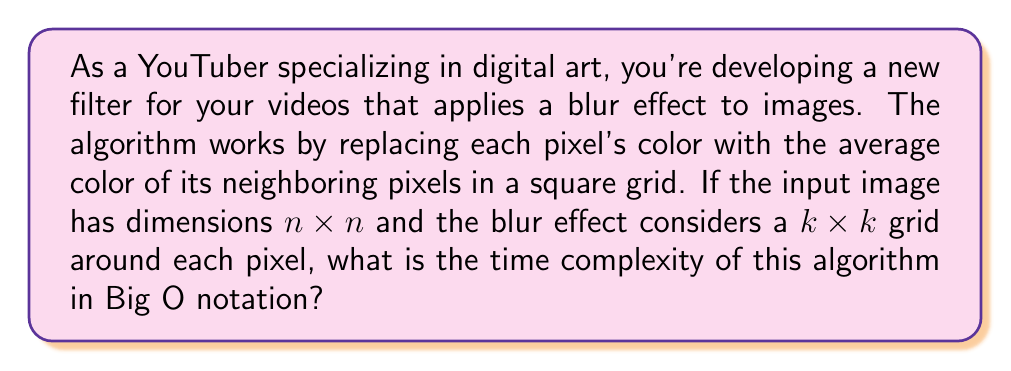Can you solve this math problem? Let's break down the problem and analyze the algorithm step by step:

1. The input image has dimensions $n \times n$, meaning there are $n^2$ total pixels to process.

2. For each pixel, we need to consider a $k \times k$ grid of neighboring pixels.

3. To calculate the average color for each pixel:
   a. We sum the color values of all pixels in the $k \times k$ grid.
   b. We divide the sum by the total number of pixels in the grid ($k^2$).

4. The number of operations for each pixel:
   - Summing the $k \times k$ grid requires $k^2$ operations.
   - The division is a constant time operation.
   - Total operations per pixel: $O(k^2)$

5. We perform these operations for all $n^2$ pixels in the image.

6. Therefore, the total number of operations is:
   $n^2 \times O(k^2) = O(n^2k^2)$

This analysis assumes that $k$ is significantly smaller than $n$, which is typically the case for blur filters. If $k$ were to approach $n$ in size, we would need to consider a different analysis.

It's worth noting that there are more efficient algorithms for blur effects, such as the box blur algorithm, which can achieve better time complexity. However, for the straightforward approach described in the question, $O(n^2k^2)$ is the correct time complexity.
Answer: The time complexity of the blur effect algorithm is $O(n^2k^2)$. 